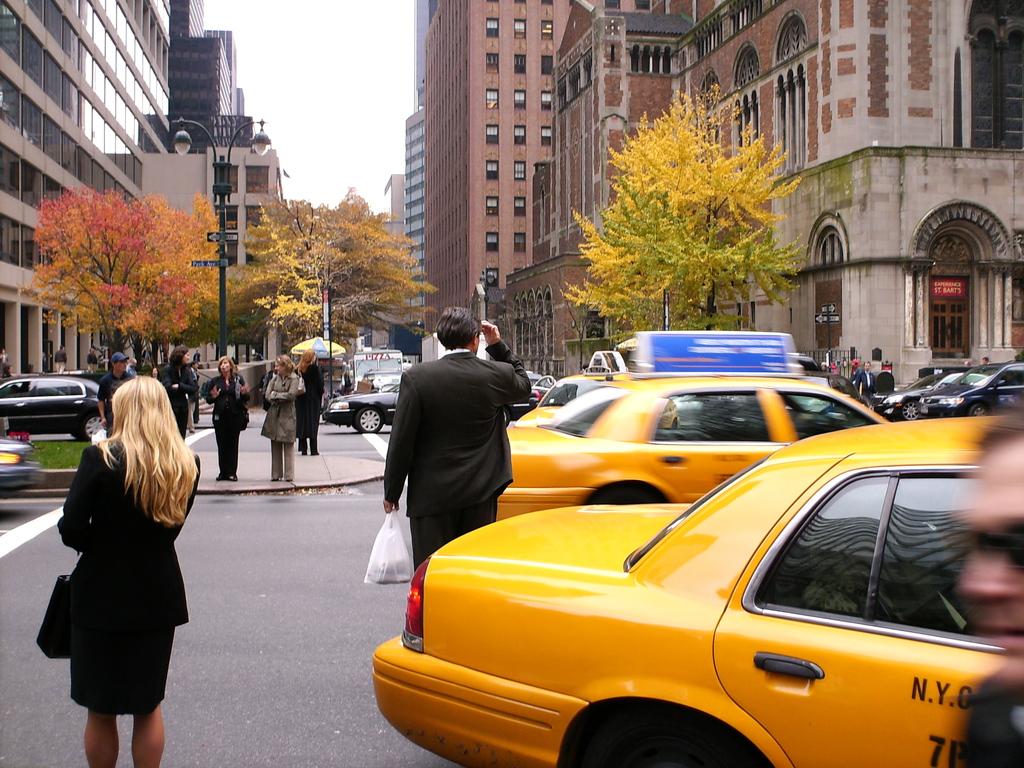What is written on the side of the taxi on the left side of this picture?
Your answer should be compact. Unanswerable. 